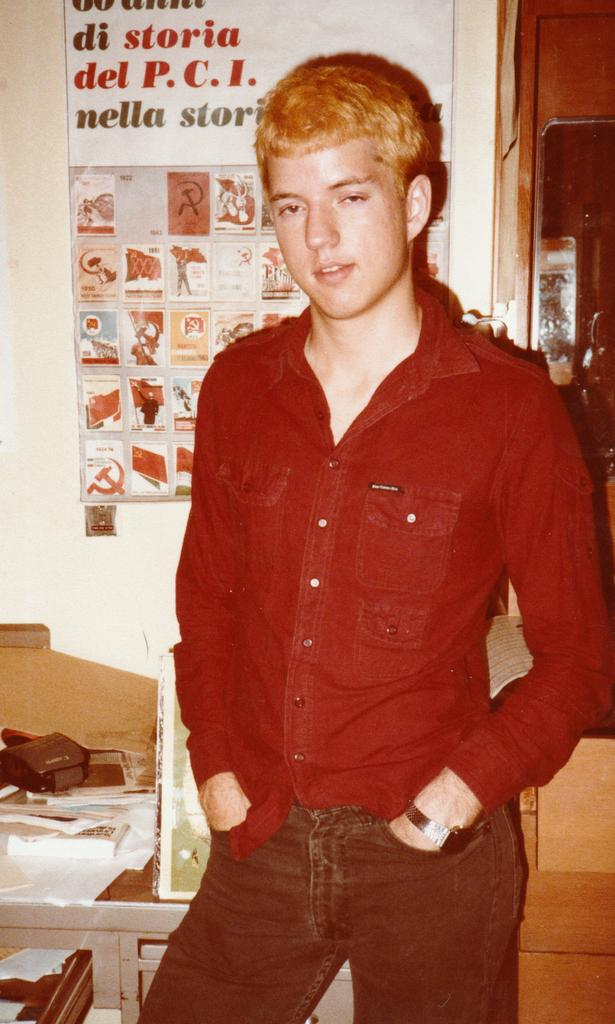Who is the main subject in the image? There is a boy in the image. What is the boy wearing? The boy is wearing a red shirt. What can be seen on the wall in the background? There is a chart stuck to the wall in the background. What architectural feature is on the right side of the image? There is a door on the right side of the image. What type of thunder can be heard in the image? There is no sound present in the image, so it is not possible to determine if any thunder can be heard. 